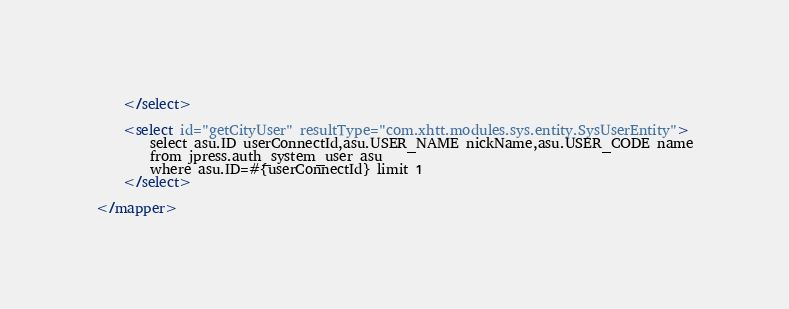Convert code to text. <code><loc_0><loc_0><loc_500><loc_500><_XML_>    </select>

    <select id="getCityUser" resultType="com.xhtt.modules.sys.entity.SysUserEntity">
        select asu.ID userConnectId,asu.USER_NAME nickName,asu.USER_CODE name
        from jpress.auth_system_user asu
        where asu.ID=#{userConnectId} limit 1
    </select>

</mapper>
</code> 